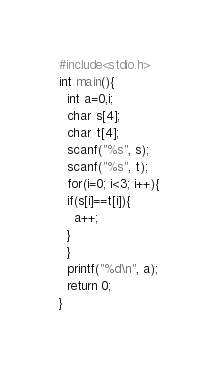Convert code to text. <code><loc_0><loc_0><loc_500><loc_500><_C_>#include<stdio.h>
int main(){
  int a=0,i;
  char s[4];
  char t[4];
  scanf("%s", s);
  scanf("%s", t);
  for(i=0; i<3; i++){
  if(s[i]==t[i]){
    a++;
  }
  }
  printf("%d\n", a);
  return 0;
}</code> 